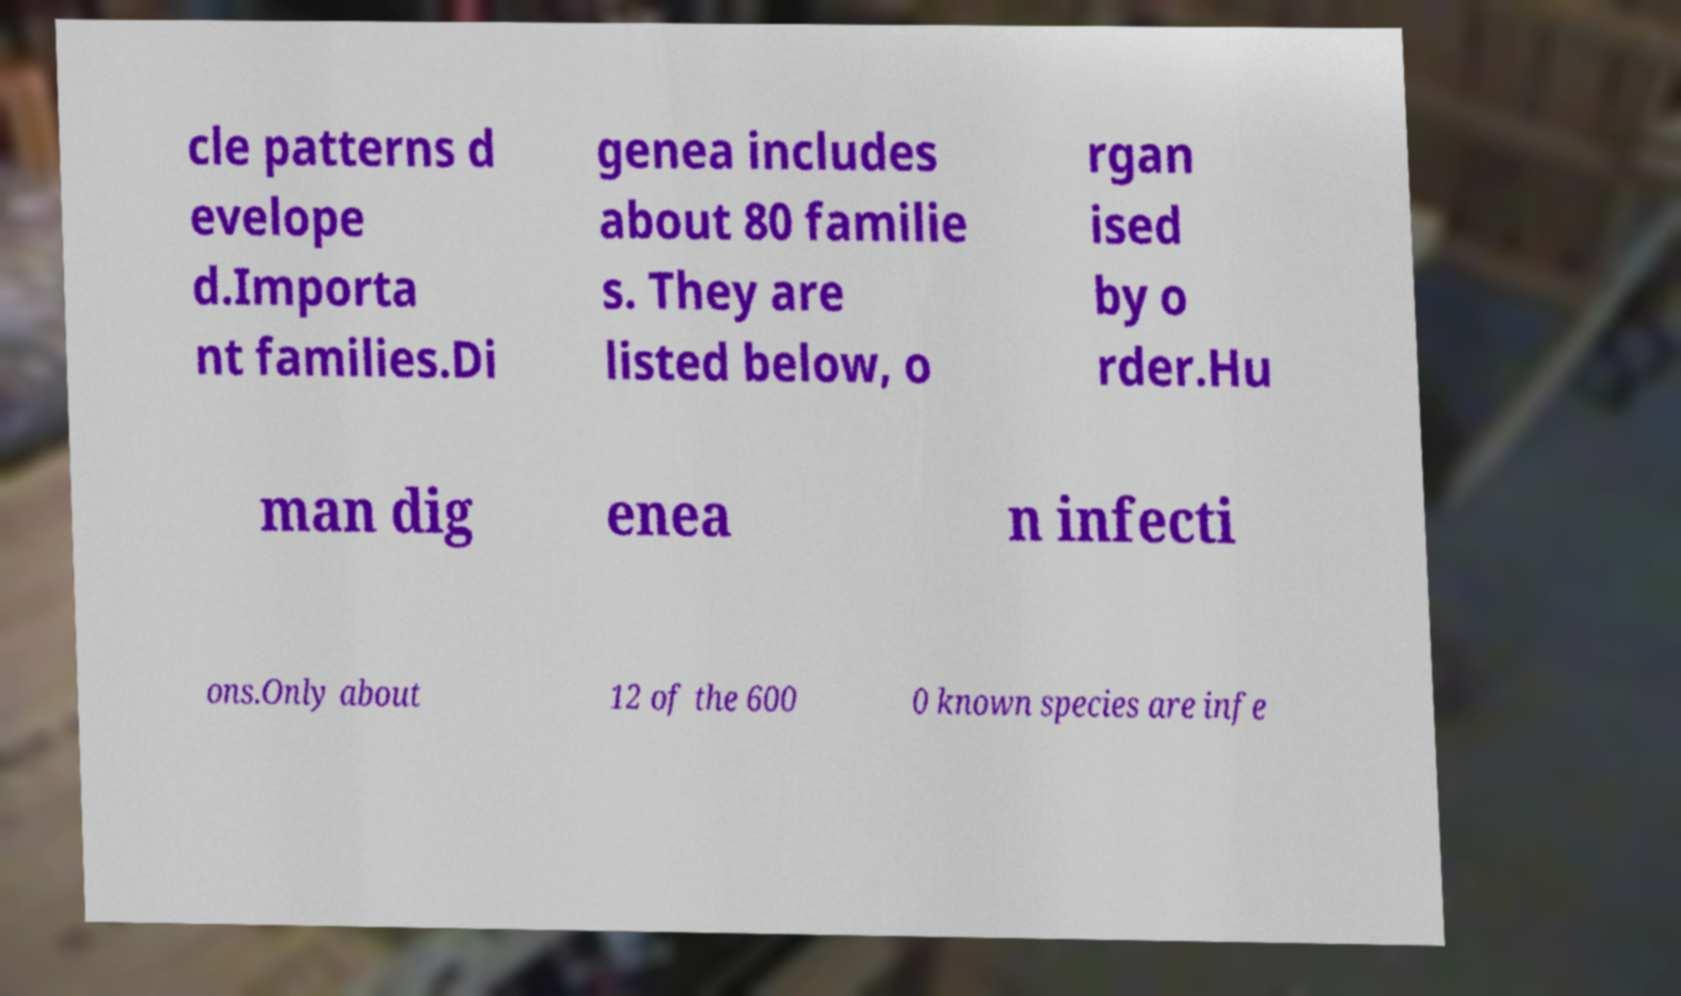Can you accurately transcribe the text from the provided image for me? cle patterns d evelope d.Importa nt families.Di genea includes about 80 familie s. They are listed below, o rgan ised by o rder.Hu man dig enea n infecti ons.Only about 12 of the 600 0 known species are infe 